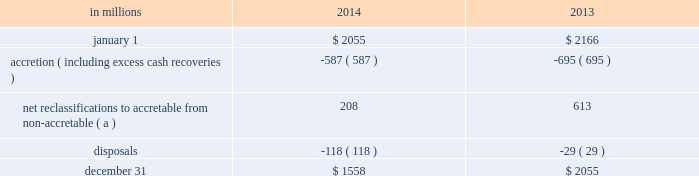During 2014 , $ 91 million of provision recapture was recorded for purchased impaired loans compared to $ 11 million of provision expense for 2013 .
The charge-offs ( which were specifically for commercial loans greater than a defined threshold ) during 2014 were $ 42 million compared to $ 104 million for 2013 .
At december 31 , 2014 , the allowance for loan and lease losses was $ .9 billion on $ 4.4 billion of purchased impaired loans while the remaining $ .5 billion of purchased impaired loans required no allowance as the net present value of expected cash flows equaled or exceeded the recorded investment .
As of december 31 , 2013 , the allowance for loan and lease losses related to purchased impaired loans was $ 1.0 billion .
If any allowance for loan losses is recognized on a purchased impaired pool , which is accounted for as a single asset , the entire balance of that pool would be disclosed as requiring an allowance .
Subsequent increases in the net present value of cash flows will result in a provision recapture of any previously recorded allowance for loan and lease losses , to the extent applicable , and/or a reclassification from non-accretable difference to accretable yield , which will be recognized prospectively .
Individual loan transactions where final dispositions have occurred ( as noted above ) result in removal of the loans from their applicable pools for cash flow estimation purposes .
The cash flow re-estimation process is completed quarterly to evaluate the appropriateness of the allowance associated with the purchased impaired loans .
Activity for the accretable yield during 2014 and 2013 follows : table 72 : purchased impaired loans 2013 accretable yield .
( a ) approximately 93% ( 93 % ) of net reclassifications for the year ended december 31 , 2014 were within the commercial portfolio as compared to 37% ( 37 % ) for year ended december 31 , 2013 .
Note 5 allowances for loan and lease losses and unfunded loan commitments and letters of credit allowance for loan and lease losses we maintain the alll at levels that we believe to be appropriate to absorb estimated probable credit losses incurred in the portfolios as of the balance sheet date .
We use the two main portfolio segments 2013 commercial lending and consumer lending 2013 and develop and document the alll under separate methodologies for each of these segments as discussed in note 1 accounting policies .
A rollforward of the alll and associated loan data is presented below .
The pnc financial services group , inc .
2013 form 10-k 143 .
What was the dollar amount in millions for net reclassifications for the year ended december 31 , 2014 due to the commercial portfolio? 
Computations: (208 * 93%)
Answer: 193.44. 